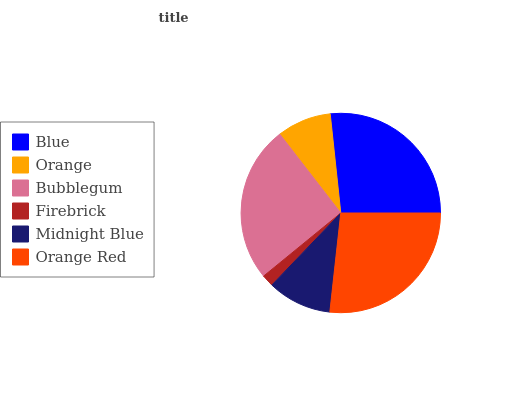Is Firebrick the minimum?
Answer yes or no. Yes. Is Orange Red the maximum?
Answer yes or no. Yes. Is Orange the minimum?
Answer yes or no. No. Is Orange the maximum?
Answer yes or no. No. Is Blue greater than Orange?
Answer yes or no. Yes. Is Orange less than Blue?
Answer yes or no. Yes. Is Orange greater than Blue?
Answer yes or no. No. Is Blue less than Orange?
Answer yes or no. No. Is Bubblegum the high median?
Answer yes or no. Yes. Is Midnight Blue the low median?
Answer yes or no. Yes. Is Blue the high median?
Answer yes or no. No. Is Orange the low median?
Answer yes or no. No. 